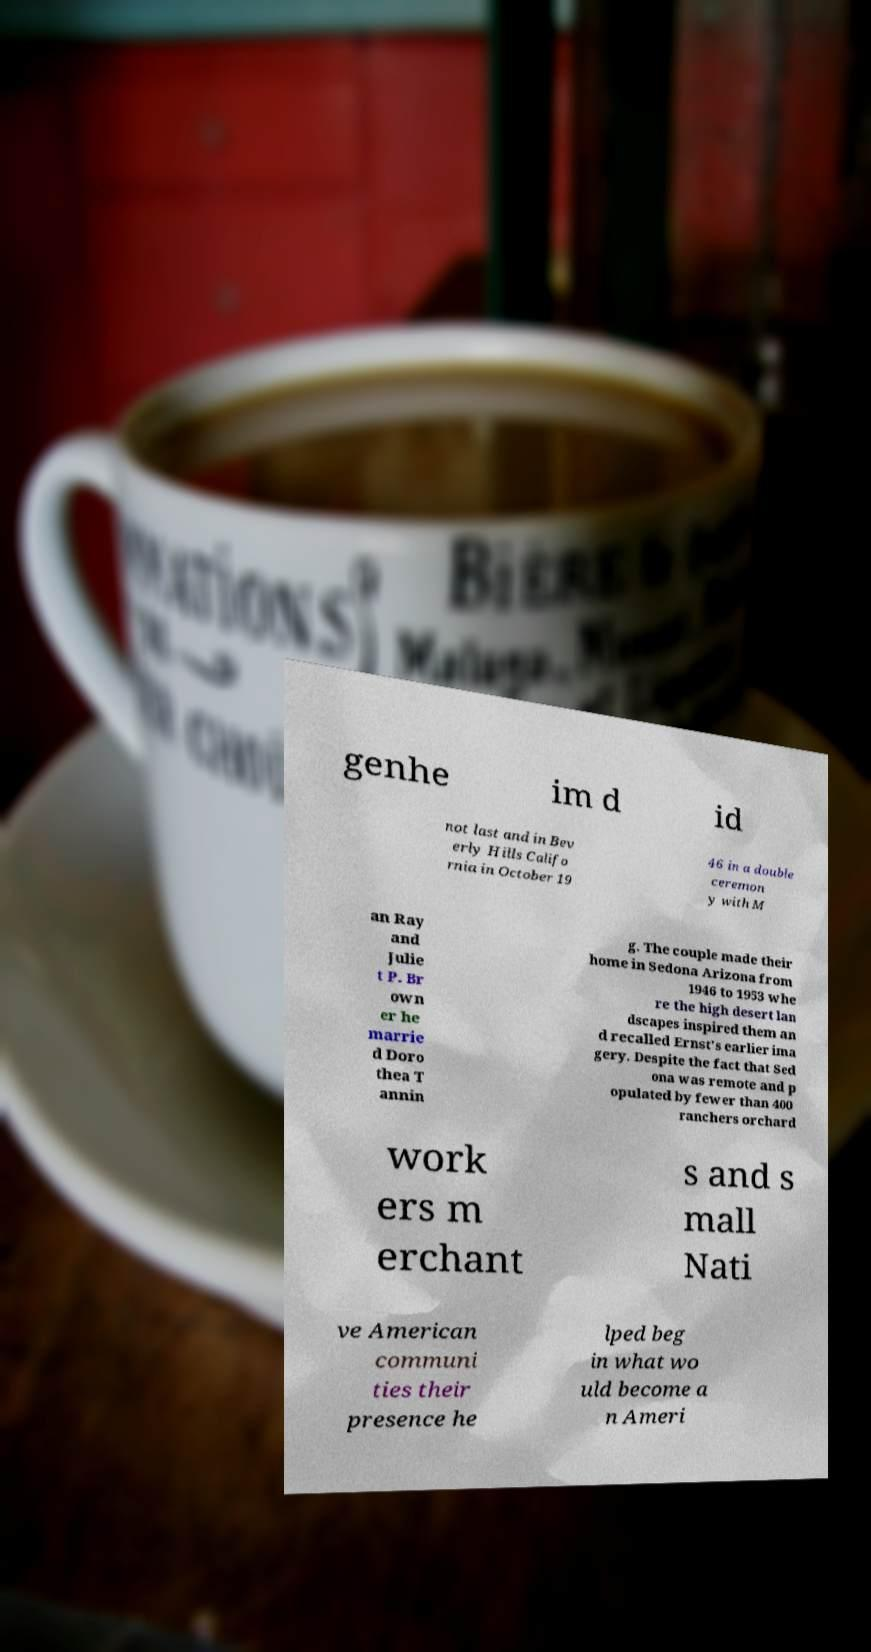What messages or text are displayed in this image? I need them in a readable, typed format. genhe im d id not last and in Bev erly Hills Califo rnia in October 19 46 in a double ceremon y with M an Ray and Julie t P. Br own er he marrie d Doro thea T annin g. The couple made their home in Sedona Arizona from 1946 to 1953 whe re the high desert lan dscapes inspired them an d recalled Ernst's earlier ima gery. Despite the fact that Sed ona was remote and p opulated by fewer than 400 ranchers orchard work ers m erchant s and s mall Nati ve American communi ties their presence he lped beg in what wo uld become a n Ameri 